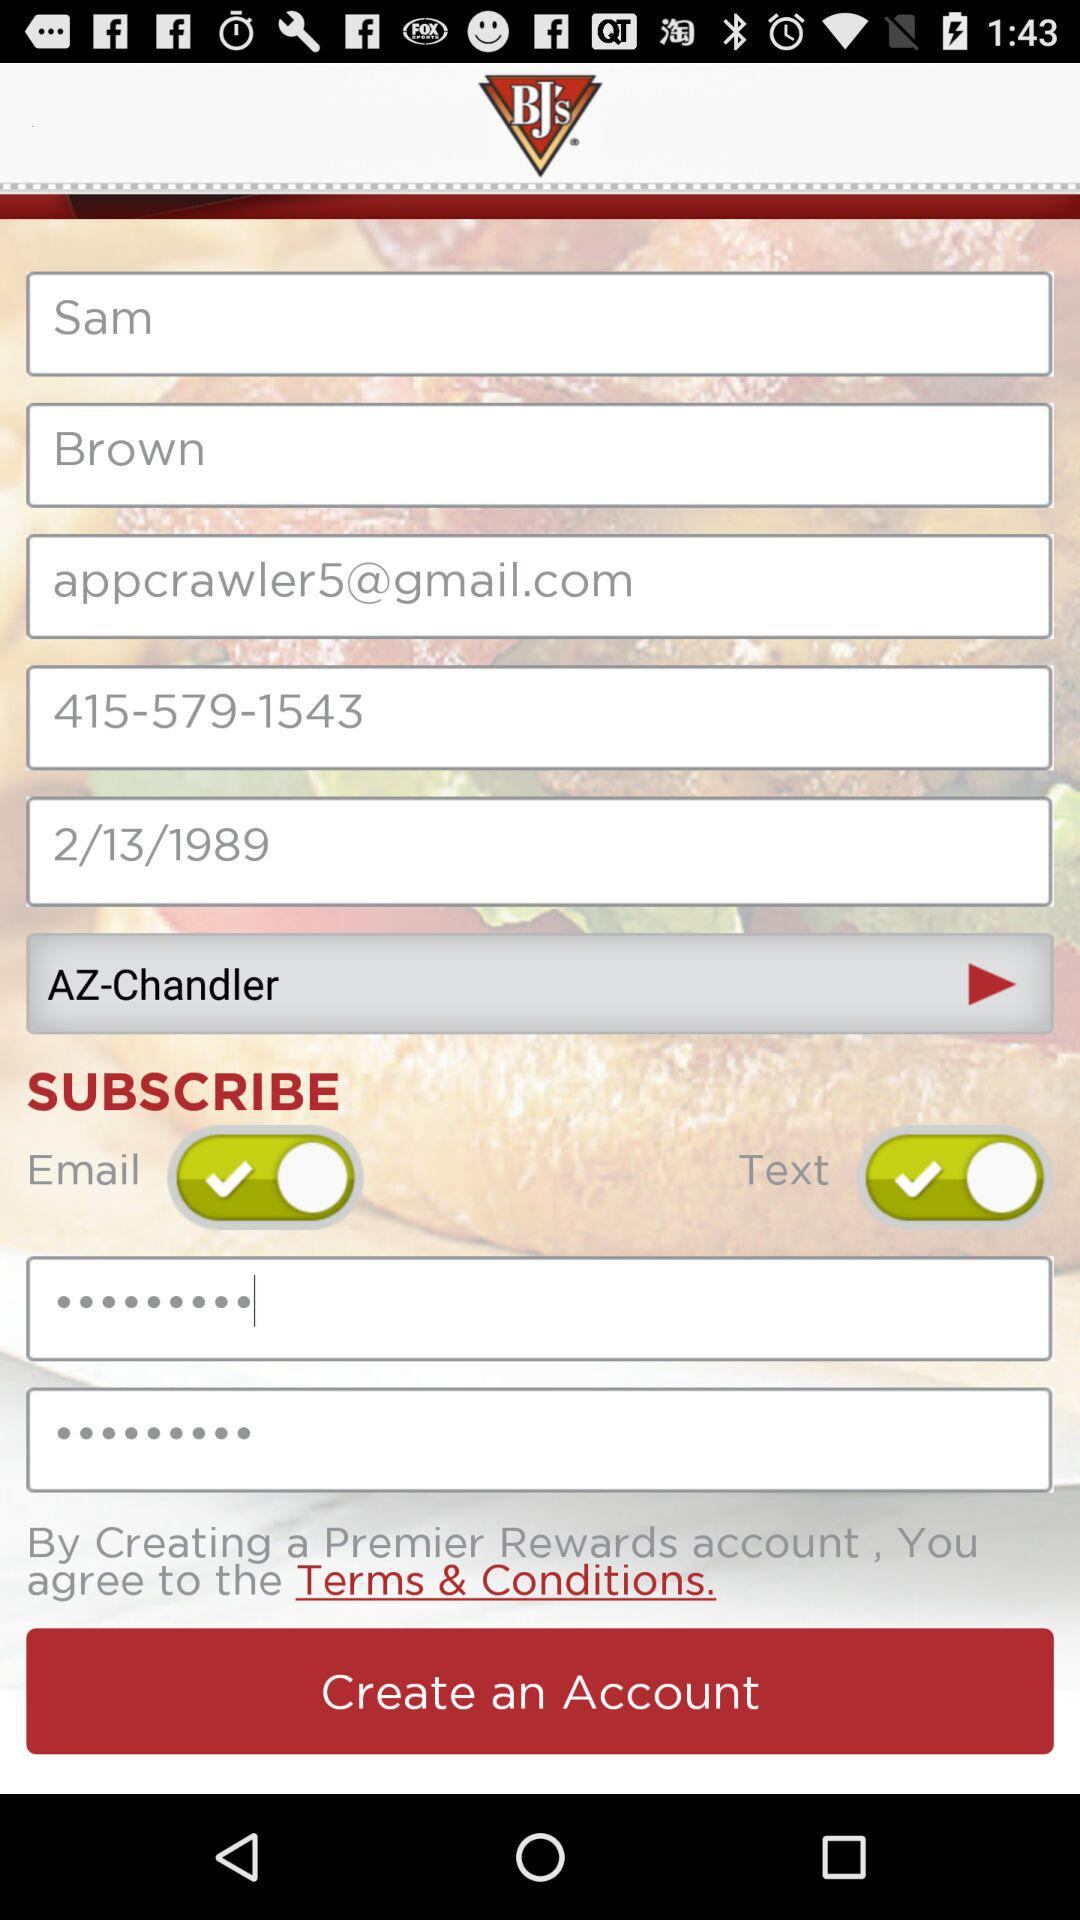What is the contact number? The contact number is 415-579-1543. 